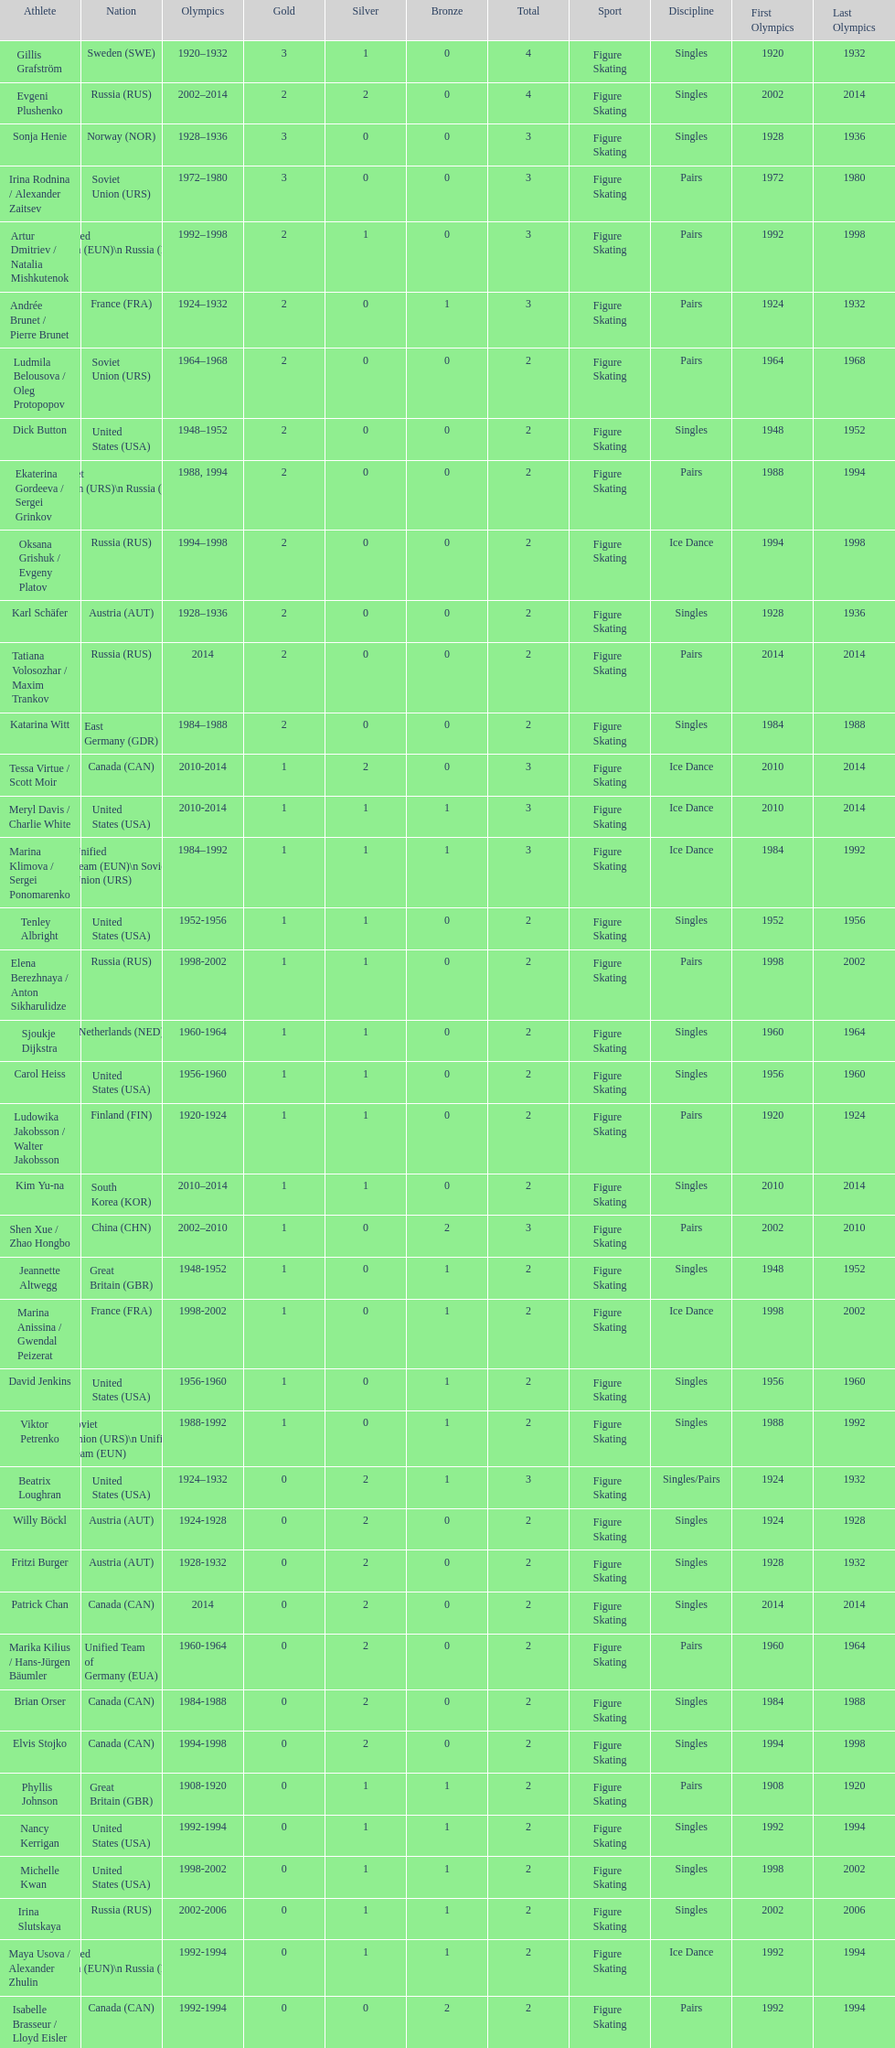Which athlete was from south korea after the year 2010? Kim Yu-na. 